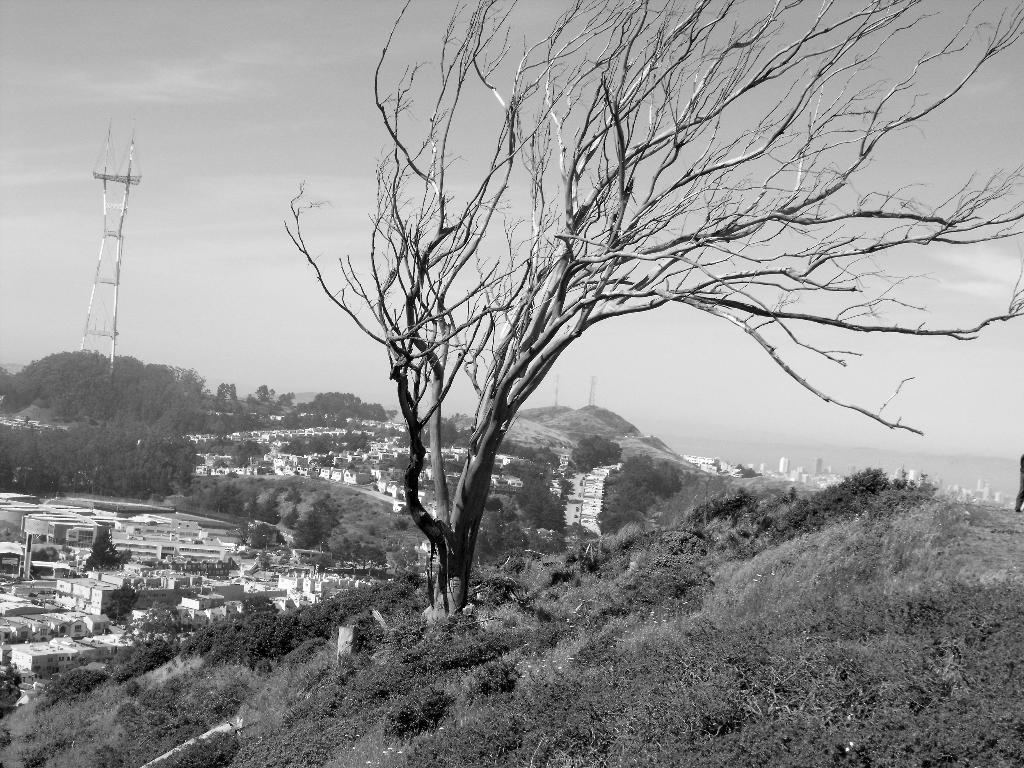What type of natural elements are present in the image? There are trees and plants in the image. What type of man-made structures can be seen in the image? There are buildings in the image. What type of infrastructure is visible in the image? Electric poles are visible in the image. What can be seen in the background of the image? The sky is visible in the background of the image. How many rings are visible on the trees in the image? There are no rings visible on the trees in the image. What type of sport is being played in the image? There is no sport being played in the image. What type of food is being produced by the plants in the image? The image does not show any specific food being produced by the plants. 